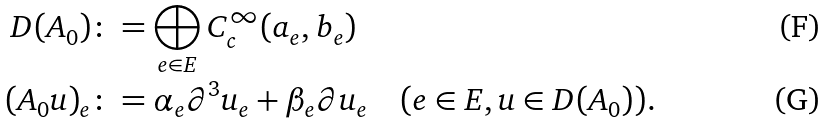Convert formula to latex. <formula><loc_0><loc_0><loc_500><loc_500>D ( A _ { 0 } ) & \colon = \bigoplus _ { e \in E } C _ { c } ^ { \infty } ( a _ { e } , b _ { e } ) \\ ( A _ { 0 } u ) _ { e } & \colon = \alpha _ { e } \partial ^ { 3 } u _ { e } + \beta _ { e } \partial u _ { e } \quad ( e \in E , u \in D ( A _ { 0 } ) ) .</formula> 